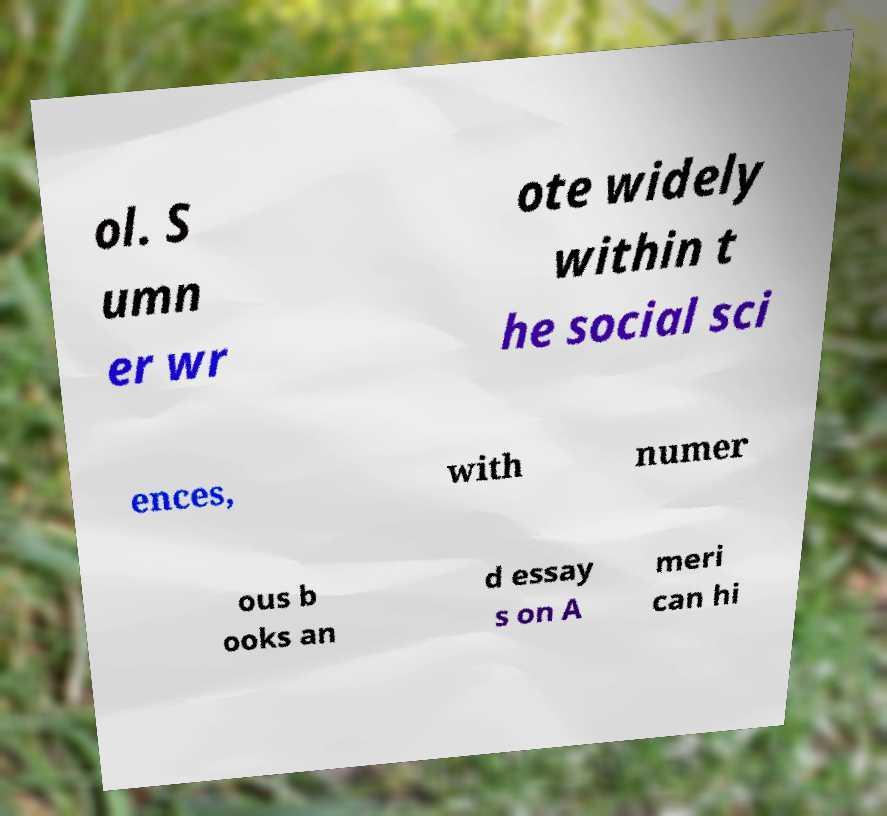I need the written content from this picture converted into text. Can you do that? ol. S umn er wr ote widely within t he social sci ences, with numer ous b ooks an d essay s on A meri can hi 